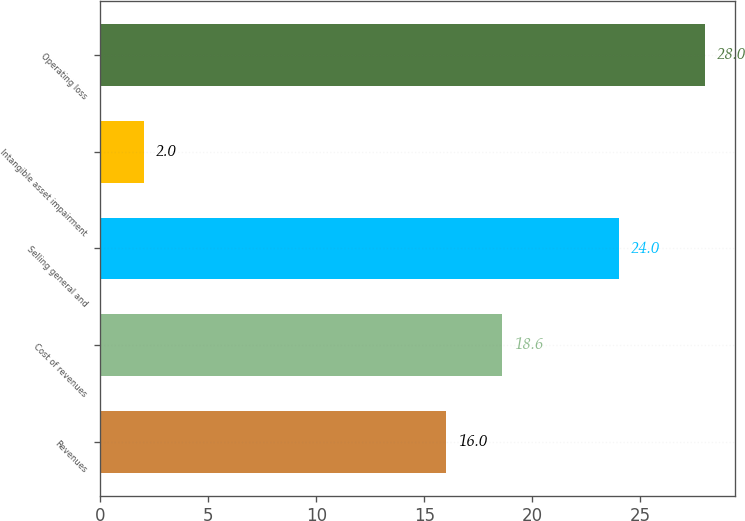Convert chart. <chart><loc_0><loc_0><loc_500><loc_500><bar_chart><fcel>Revenues<fcel>Cost of revenues<fcel>Selling general and<fcel>Intangible asset impairment<fcel>Operating loss<nl><fcel>16<fcel>18.6<fcel>24<fcel>2<fcel>28<nl></chart> 